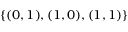<formula> <loc_0><loc_0><loc_500><loc_500>\{ ( 0 , 1 ) , ( 1 , 0 ) , ( 1 , 1 ) \}</formula> 